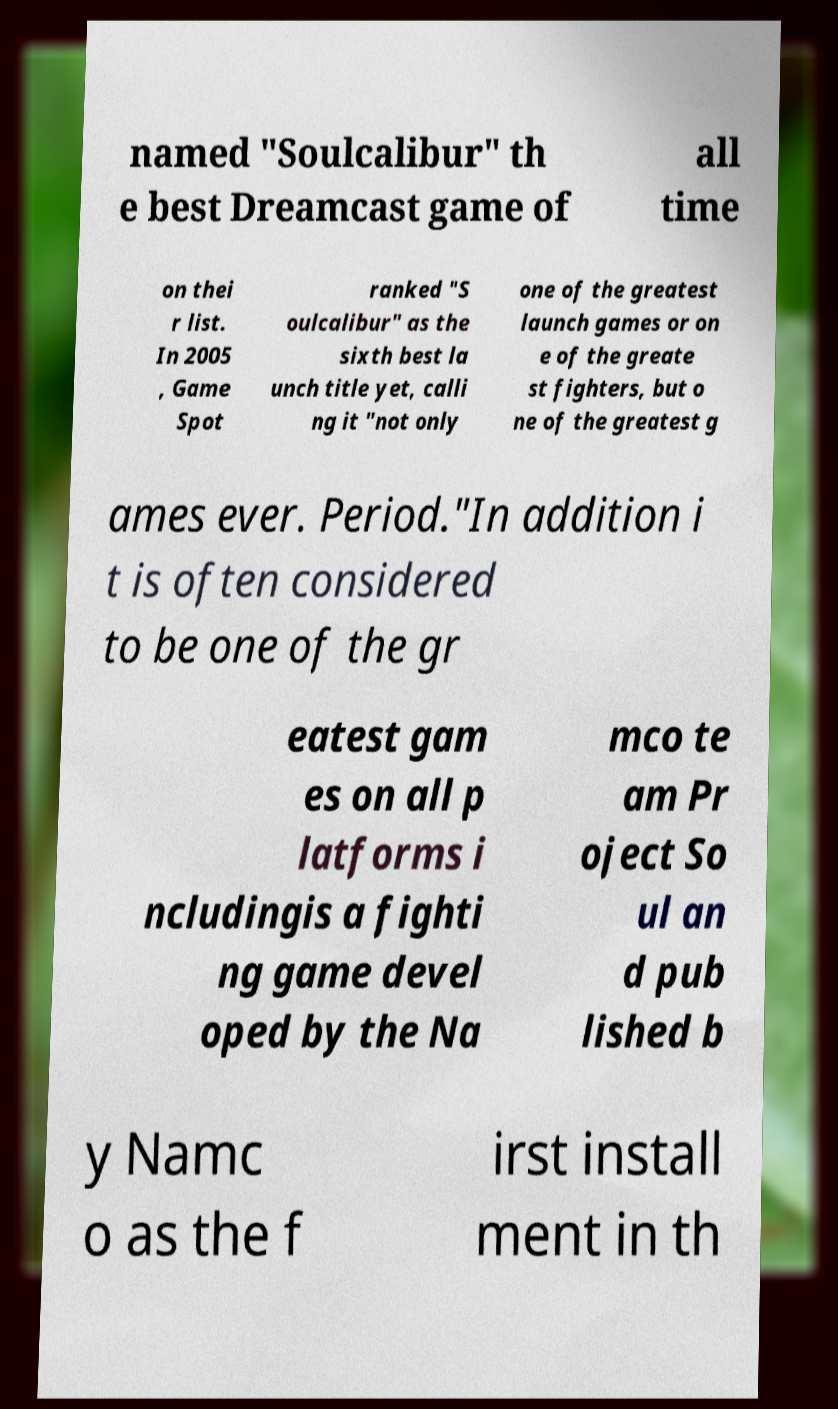Can you accurately transcribe the text from the provided image for me? named "Soulcalibur" th e best Dreamcast game of all time on thei r list. In 2005 , Game Spot ranked "S oulcalibur" as the sixth best la unch title yet, calli ng it "not only one of the greatest launch games or on e of the greate st fighters, but o ne of the greatest g ames ever. Period."In addition i t is often considered to be one of the gr eatest gam es on all p latforms i ncludingis a fighti ng game devel oped by the Na mco te am Pr oject So ul an d pub lished b y Namc o as the f irst install ment in th 